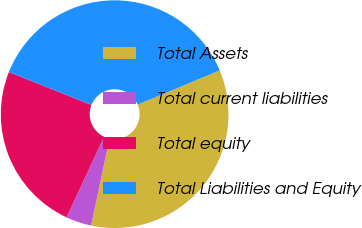Convert chart. <chart><loc_0><loc_0><loc_500><loc_500><pie_chart><fcel>Total Assets<fcel>Total current liabilities<fcel>Total equity<fcel>Total Liabilities and Equity<nl><fcel>34.59%<fcel>3.63%<fcel>24.09%<fcel>37.69%<nl></chart> 